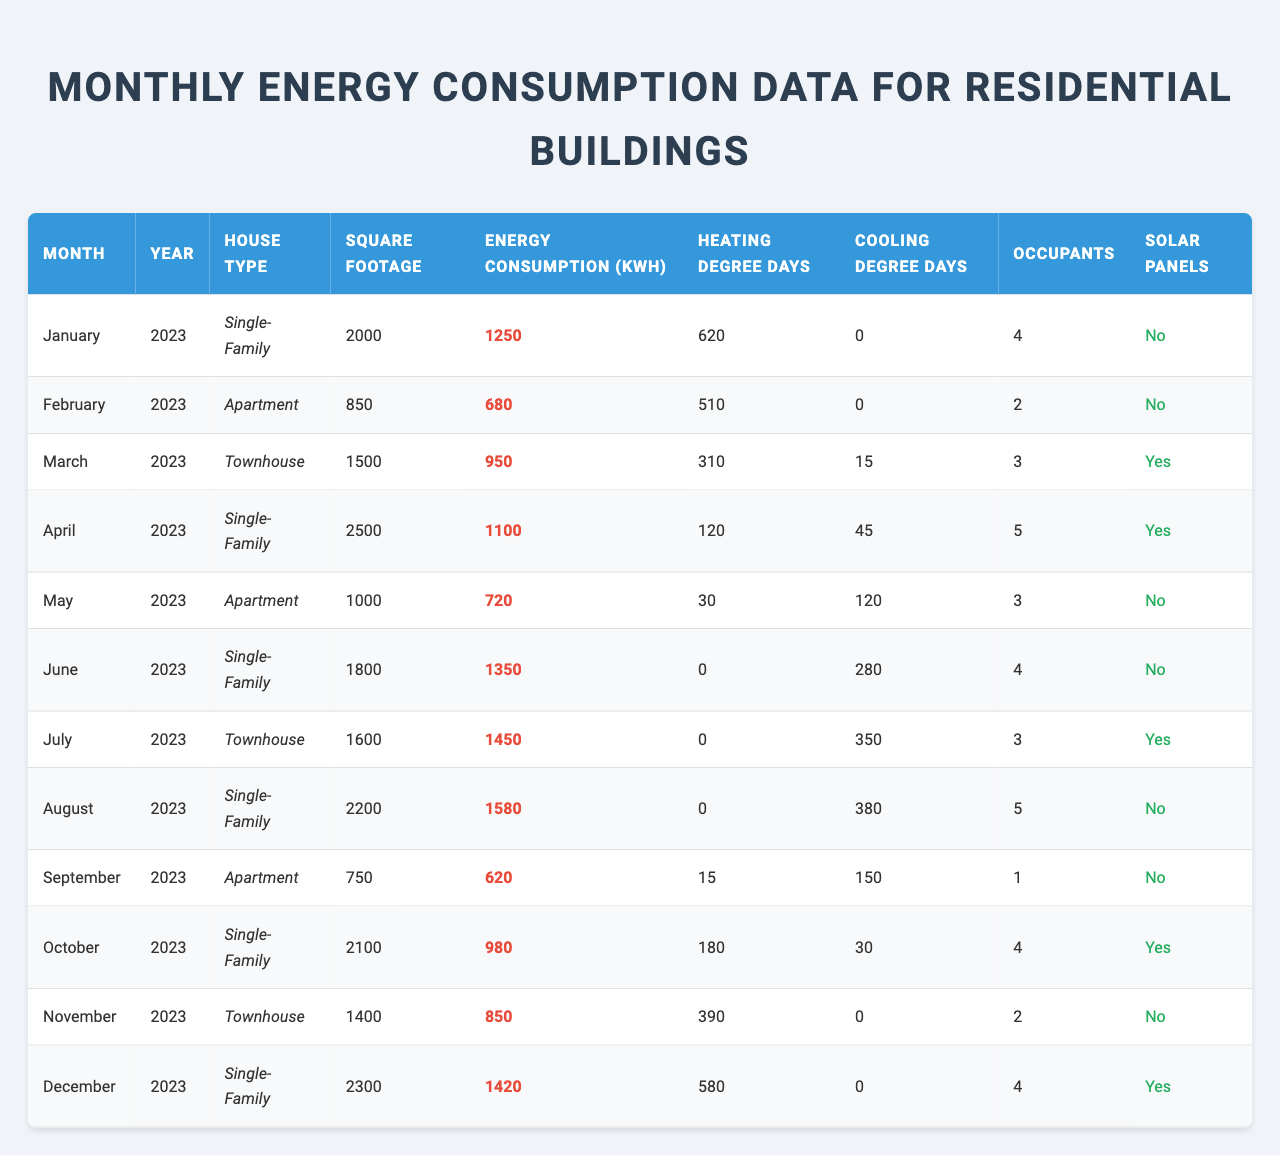What is the energy consumption of the apartment in February 2023? In the table, find the row corresponding to February 2023 and the house type "Apartment." The energy consumption listed for that month is 680 kWh.
Answer: 680 kWh How many occupants live in the single-family house in June 2023? Look at the entry for June 2023 where the house type is "Single-family." The table indicates that there are 4 occupants.
Answer: 4 occupants Which month had the highest energy consumption and what was the value? Check all the rows for energy consumption values, identifying August 2023, which shows the highest consumption of 1580 kWh.
Answer: August 2023, 1580 kWh What is the average energy consumption for all single-family houses? Identify the rows for single-family houses and their respective energy consumptions (1250, 1100, 1350, 1580, 980, 1420). The average is calculated as (1250 + 1100 + 1350 + 1580 + 980 + 1420) / 6 = 1285 kWh.
Answer: 1285 kWh Which month in 2023 had the lowest heating degree days and what was the value? Review the heating degree days column to find the lowest value, which is 0 in June and July 2023.
Answer: June and July 2023, 0 Did any houses with solar panels installed have higher energy consumption than 1000 kWh? Filter the rows with solar panels ("Yes") and check their energy consumption values. The rows for March (950 kWh), April (1100 kWh), July (1450 kWh), October (980 kWh), and December (1420 kWh) show that April, July, and December exceed 1000 kWh.
Answer: Yes How does the energy consumption of the townhouse in March compare to other townhouses? Look at all townhouse entries: March (950 kWh) and July (1450 kWh). Thus, March's consumption is lower than July's.
Answer: Lower than July What percentage of houses had solar panels installed? Count the total houses (12) and those with solar panels (6). The percentage is calculated as (6/12) * 100 = 50%.
Answer: 50% In December 2023, how does energy consumption compare to that of January 2023? Compare the December entry (1420 kWh) and January entry (1250 kWh) to see that December's consumption is higher by 170 kWh.
Answer: Higher by 170 kWh How many total heating degree days were recorded from March to May 2023? Sum the heating degree days for March (310), April (120), and May (30), which results in 310 + 120 + 30 = 460.
Answer: 460 Identify any trends in energy consumption from January to August 2023. Compare the energy consumption amounts: January (1250), February (680), March (950), April (1100), May (720), June (1350), July (1450), and August (1580). The trend shows fluctuations, with an increasing pattern after May.
Answer: Fluctuating, increasing after May 